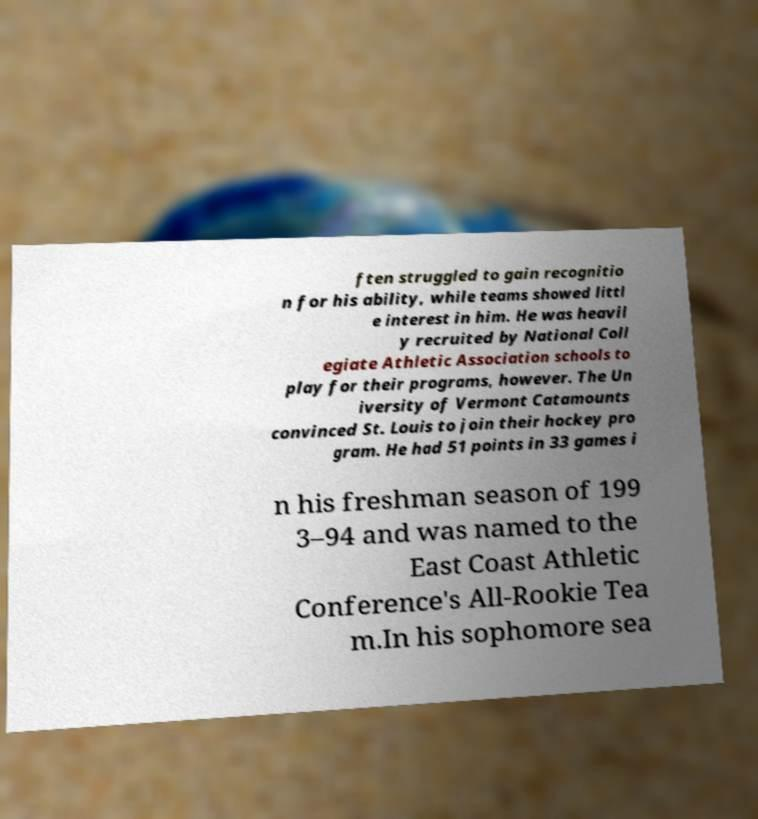What messages or text are displayed in this image? I need them in a readable, typed format. ften struggled to gain recognitio n for his ability, while teams showed littl e interest in him. He was heavil y recruited by National Coll egiate Athletic Association schools to play for their programs, however. The Un iversity of Vermont Catamounts convinced St. Louis to join their hockey pro gram. He had 51 points in 33 games i n his freshman season of 199 3–94 and was named to the East Coast Athletic Conference's All-Rookie Tea m.In his sophomore sea 